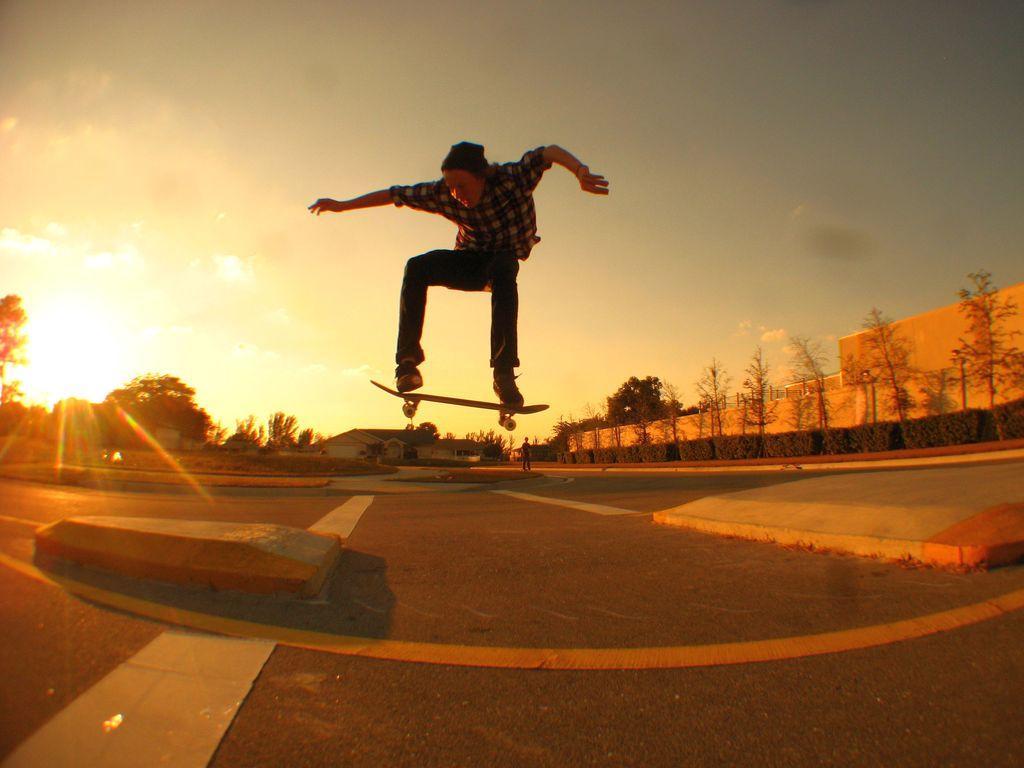Describe this image in one or two sentences. In this image I can see in the middle a boy is jumping with a skateboard. On the right side there are trees and it looks like a building. At the top it is the sky, at the bottom it is the road. 